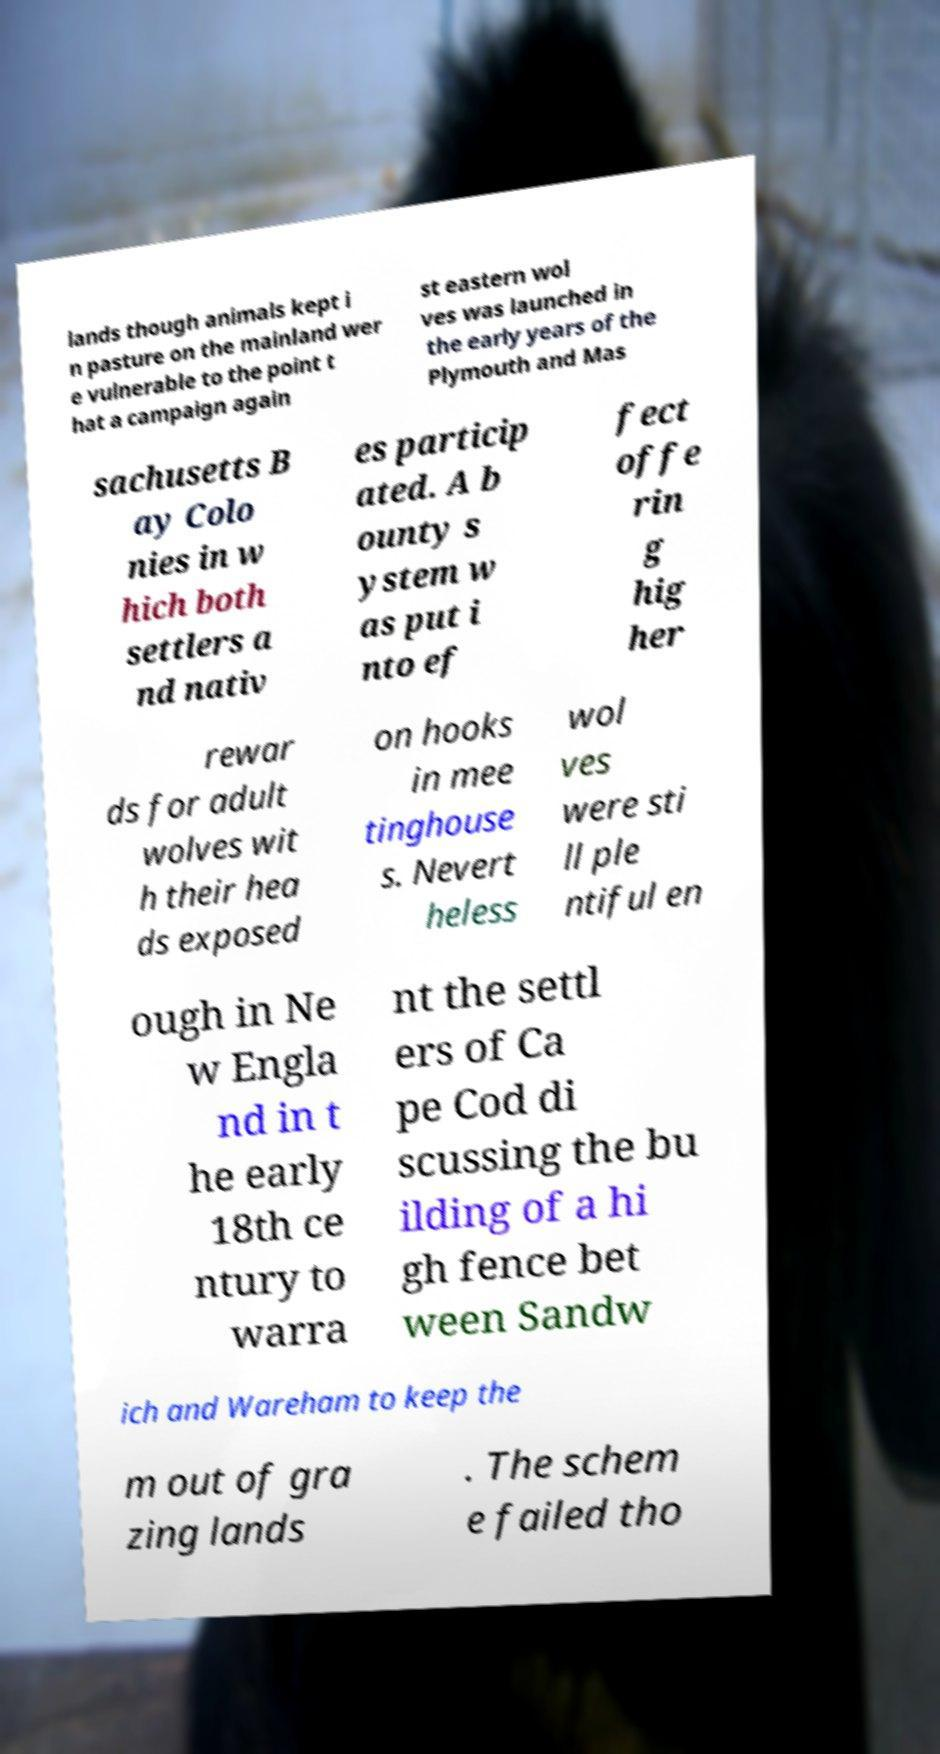Can you accurately transcribe the text from the provided image for me? lands though animals kept i n pasture on the mainland wer e vulnerable to the point t hat a campaign again st eastern wol ves was launched in the early years of the Plymouth and Mas sachusetts B ay Colo nies in w hich both settlers a nd nativ es particip ated. A b ounty s ystem w as put i nto ef fect offe rin g hig her rewar ds for adult wolves wit h their hea ds exposed on hooks in mee tinghouse s. Nevert heless wol ves were sti ll ple ntiful en ough in Ne w Engla nd in t he early 18th ce ntury to warra nt the settl ers of Ca pe Cod di scussing the bu ilding of a hi gh fence bet ween Sandw ich and Wareham to keep the m out of gra zing lands . The schem e failed tho 